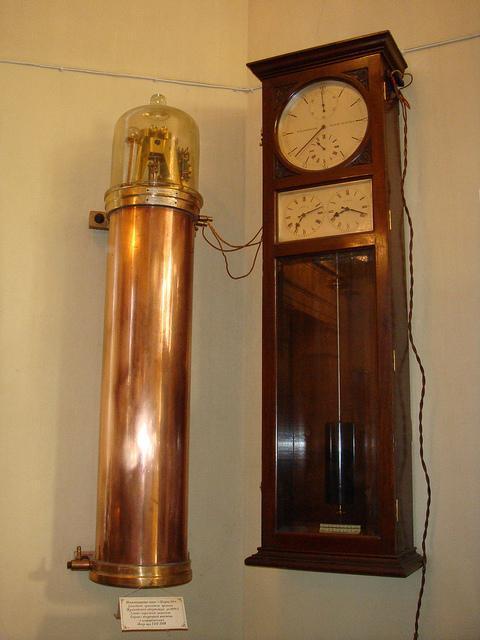How many beds are here?
Give a very brief answer. 0. 